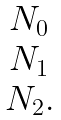Convert formula to latex. <formula><loc_0><loc_0><loc_500><loc_500>\begin{matrix} N _ { 0 } \\ N _ { 1 } \\ N _ { 2 } . \end{matrix}</formula> 